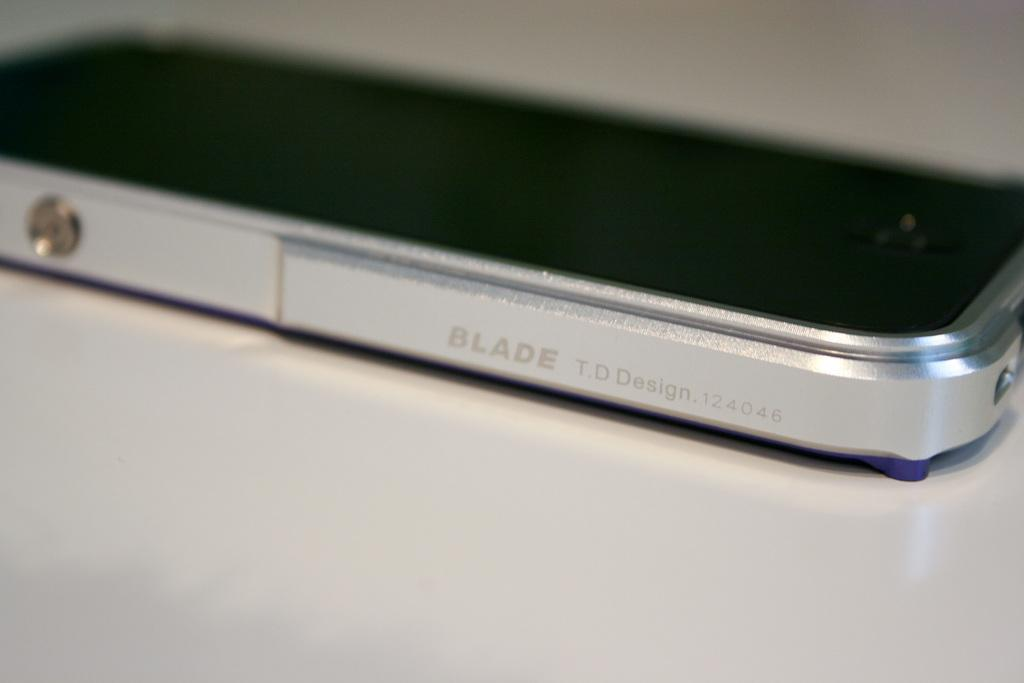Provide a one-sentence caption for the provided image. the word blade is on the side of a phone. 